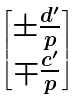<formula> <loc_0><loc_0><loc_500><loc_500>\begin{bmatrix} \pm \frac { d ^ { \prime } } { p } \\ \mp \frac { c ^ { \prime } } { p } \end{bmatrix}</formula> 